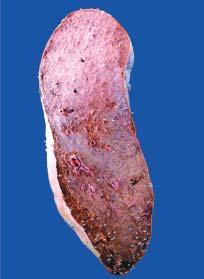s the colour of sectioned surface grey-tan?
Answer the question using a single word or phrase. Yes 